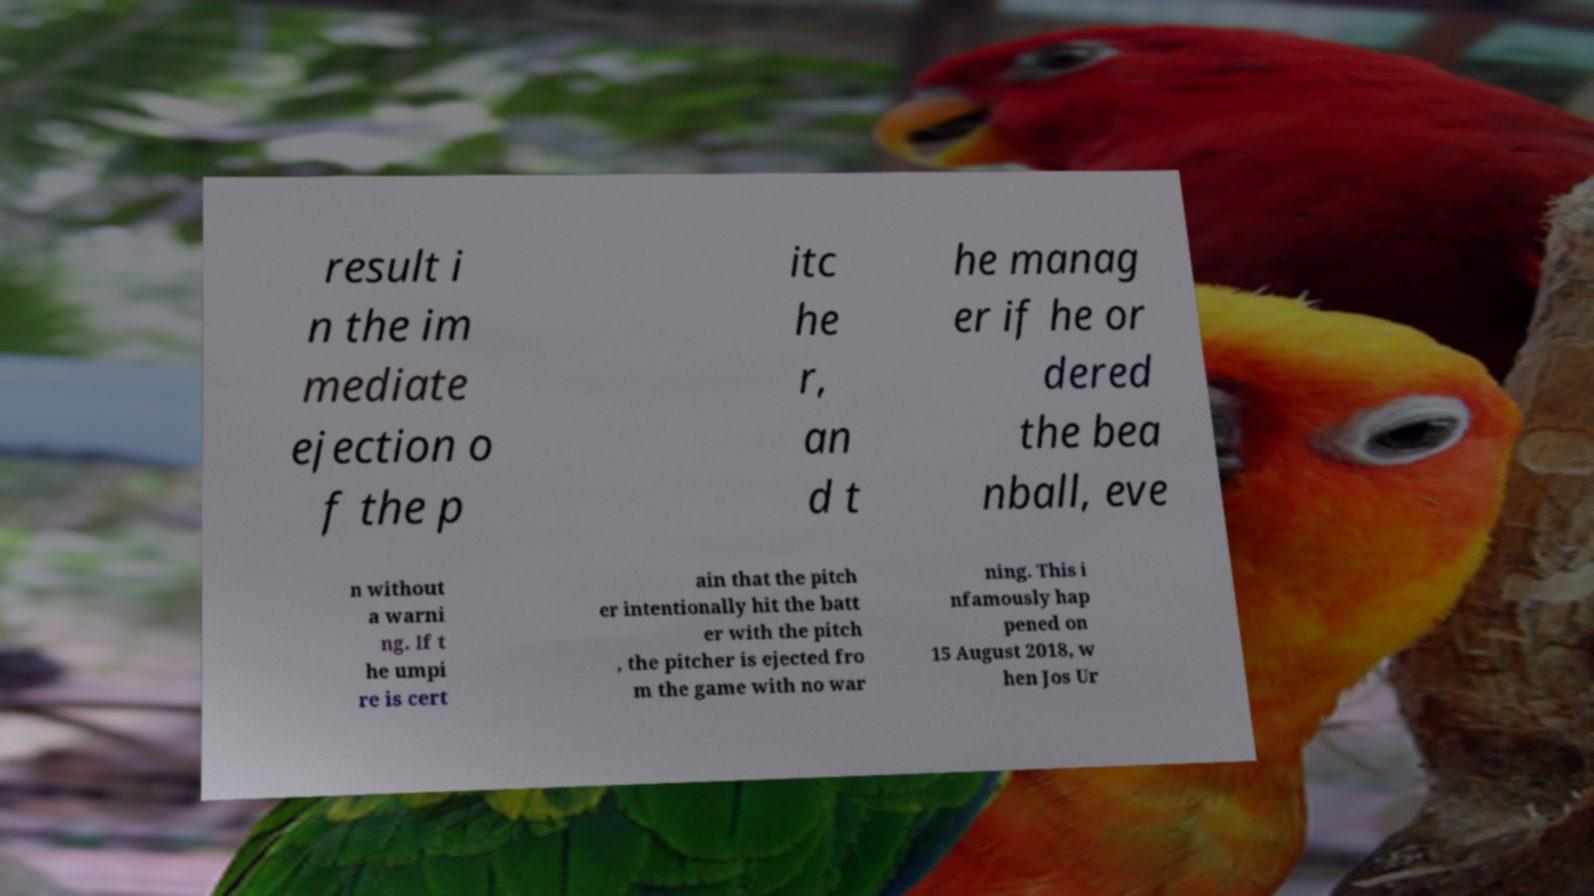Please read and relay the text visible in this image. What does it say? result i n the im mediate ejection o f the p itc he r, an d t he manag er if he or dered the bea nball, eve n without a warni ng. If t he umpi re is cert ain that the pitch er intentionally hit the batt er with the pitch , the pitcher is ejected fro m the game with no war ning. This i nfamously hap pened on 15 August 2018, w hen Jos Ur 